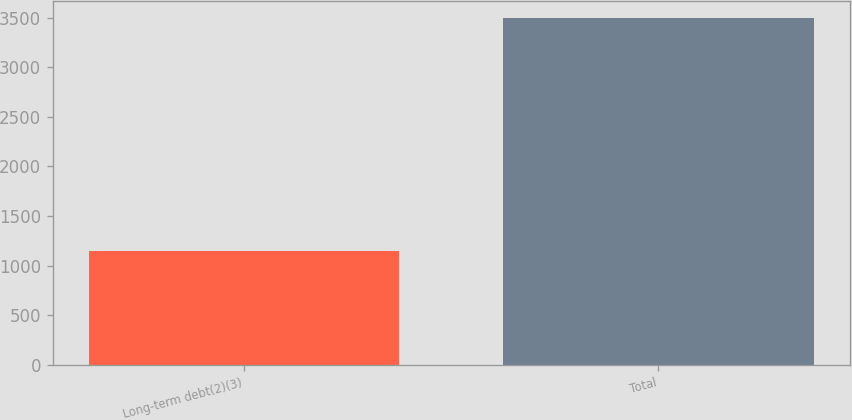Convert chart to OTSL. <chart><loc_0><loc_0><loc_500><loc_500><bar_chart><fcel>Long-term debt(2)(3)<fcel>Total<nl><fcel>1150<fcel>3494<nl></chart> 